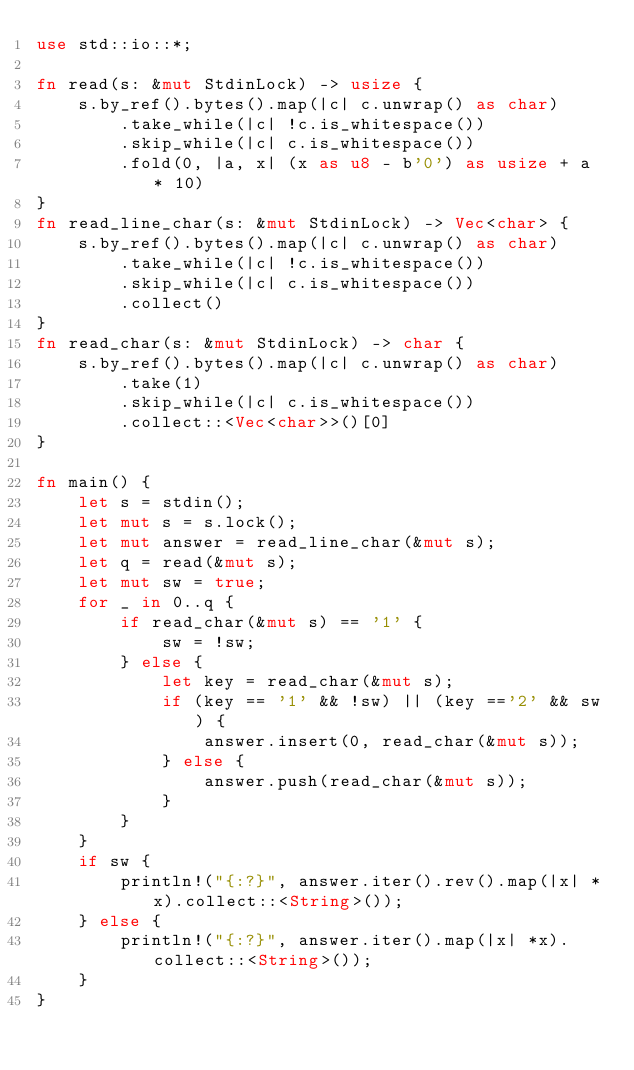Convert code to text. <code><loc_0><loc_0><loc_500><loc_500><_Rust_>use std::io::*;

fn read(s: &mut StdinLock) -> usize {
    s.by_ref().bytes().map(|c| c.unwrap() as char)
        .take_while(|c| !c.is_whitespace())
        .skip_while(|c| c.is_whitespace())
        .fold(0, |a, x| (x as u8 - b'0') as usize + a * 10)
}
fn read_line_char(s: &mut StdinLock) -> Vec<char> {
    s.by_ref().bytes().map(|c| c.unwrap() as char)
        .take_while(|c| !c.is_whitespace())
        .skip_while(|c| c.is_whitespace())
        .collect()
}
fn read_char(s: &mut StdinLock) -> char {
    s.by_ref().bytes().map(|c| c.unwrap() as char)
        .take(1)
        .skip_while(|c| c.is_whitespace())
        .collect::<Vec<char>>()[0]
}

fn main() {
    let s = stdin();
    let mut s = s.lock();
    let mut answer = read_line_char(&mut s);
    let q = read(&mut s);
    let mut sw = true;
    for _ in 0..q {
        if read_char(&mut s) == '1' {
            sw = !sw;
        } else {
            let key = read_char(&mut s);
            if (key == '1' && !sw) || (key =='2' && sw) {
                answer.insert(0, read_char(&mut s));
            } else {
                answer.push(read_char(&mut s));
            }
        }
    }
    if sw {
        println!("{:?}", answer.iter().rev().map(|x| *x).collect::<String>());
    } else {
        println!("{:?}", answer.iter().map(|x| *x).collect::<String>());
    }
}</code> 